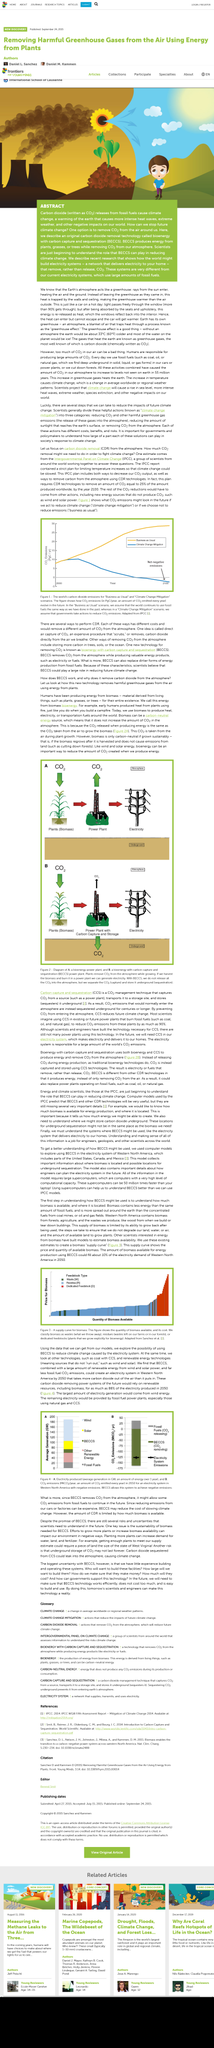Mention a couple of crucial points in this snapshot. Bioenergy with Carbon Capture and Sequestration," commonly referred to as BECCS, is a technology that involves the production of renewable energy from biomass, followed by the capture of carbon dioxide emissions, and the storage of the captured carbon in underground reservoirs for long-term sequestration. One effective way to remove CO2 from the air around us is to use plants such as flowers and trees. These plants have the ability to absorb CO2 from the atmosphere through the process of photosynthesis, converting it into oxygen and storing the excess as carbon in their tissues. By promoting the growth of these plants, we can increase the amount of CO2 that is removed from the air and contribute to a healthier, more sustainable environment. Yes, carbon dioxide can cause climate change. When it is released from fossil fuels, it contributes to global warming. 